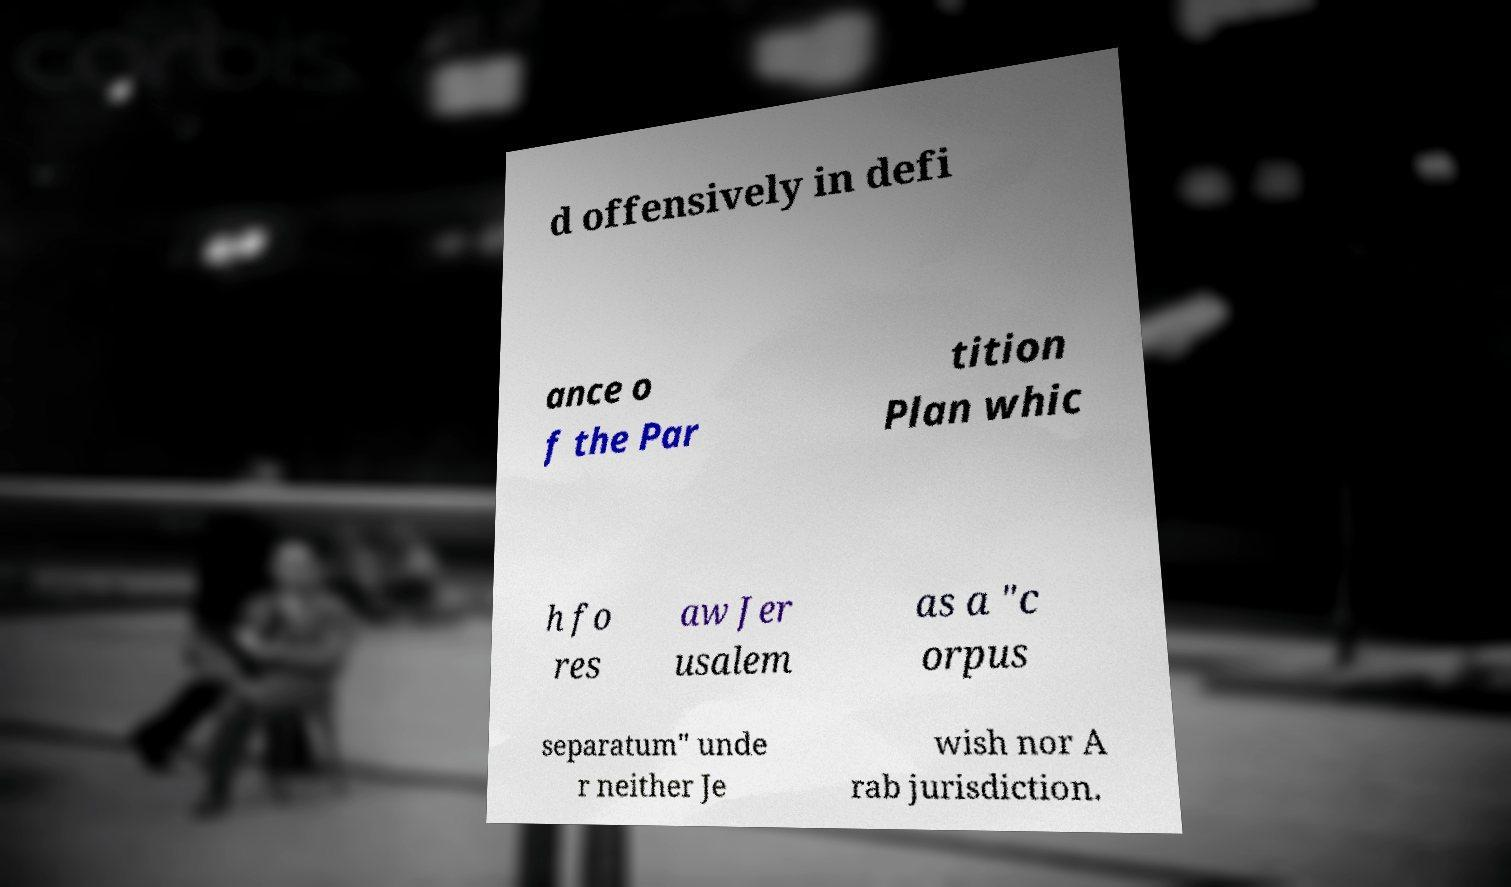Can you read and provide the text displayed in the image?This photo seems to have some interesting text. Can you extract and type it out for me? d offensively in defi ance o f the Par tition Plan whic h fo res aw Jer usalem as a "c orpus separatum" unde r neither Je wish nor A rab jurisdiction. 